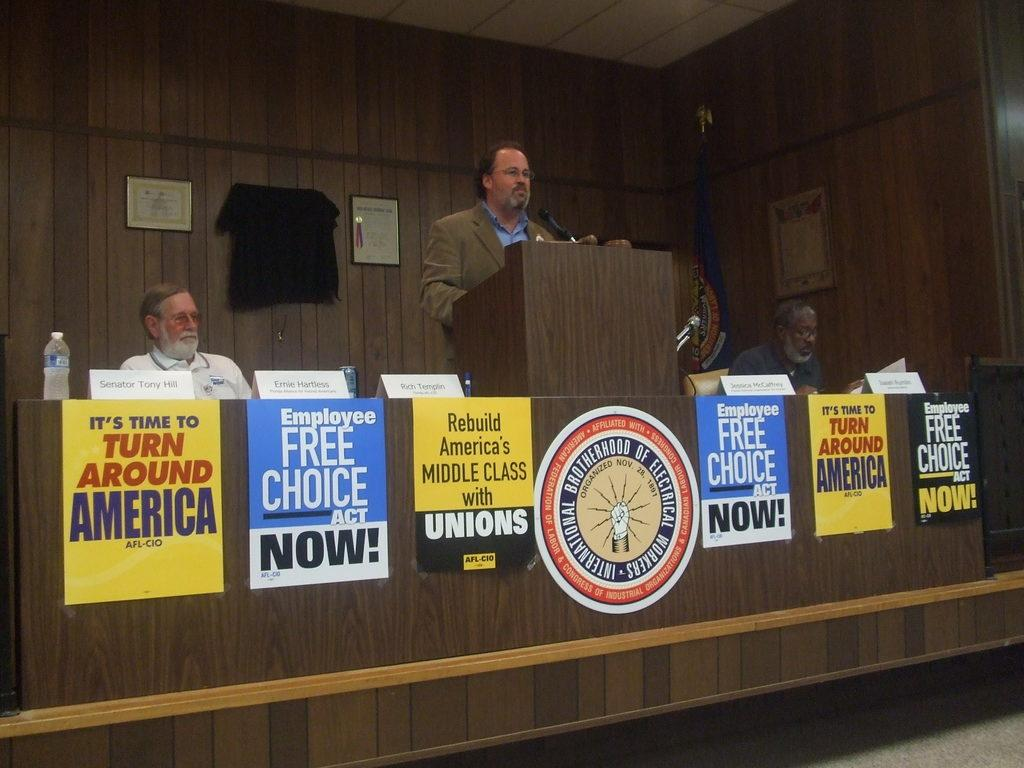<image>
Offer a succinct explanation of the picture presented. The yellow sign on the left says It's Time to Turn Around America 